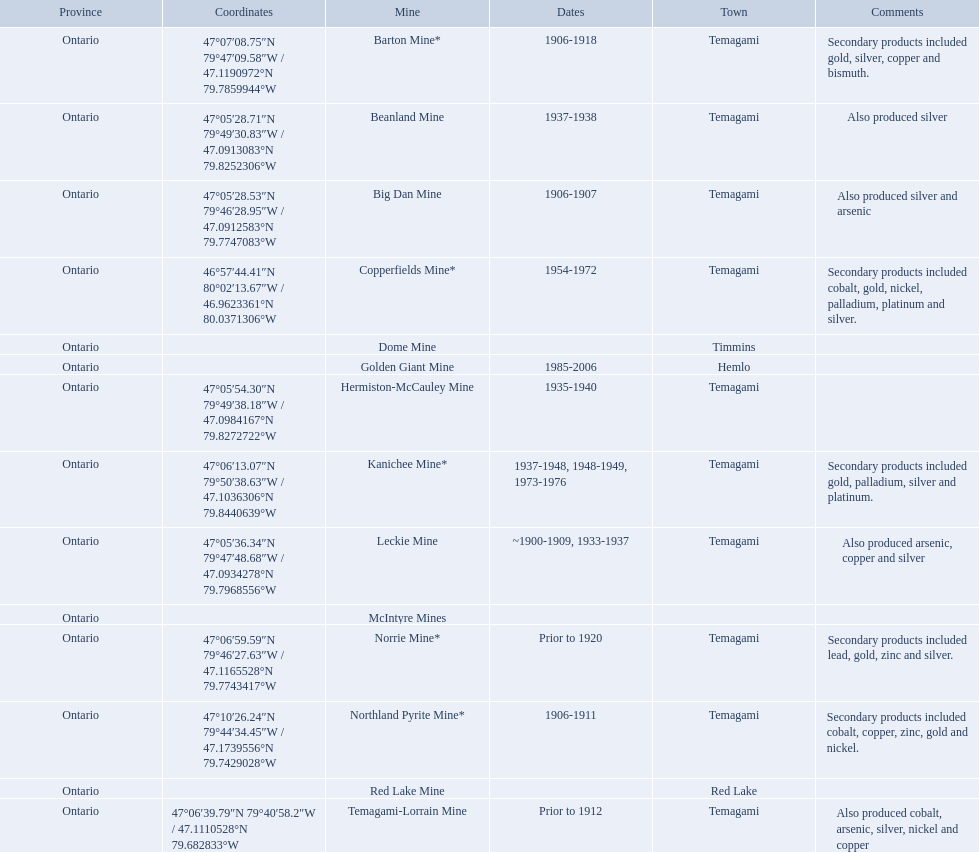What dates was the golden giant mine open? 1985-2006. What dates was the beanland mine open? 1937-1938. Of those mines, which was open longer? Golden Giant Mine. 